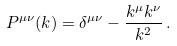Convert formula to latex. <formula><loc_0><loc_0><loc_500><loc_500>P ^ { \mu \nu } ( k ) = \delta ^ { \mu \nu } - \frac { k ^ { \mu } k ^ { \nu } } { k ^ { 2 } } \, .</formula> 